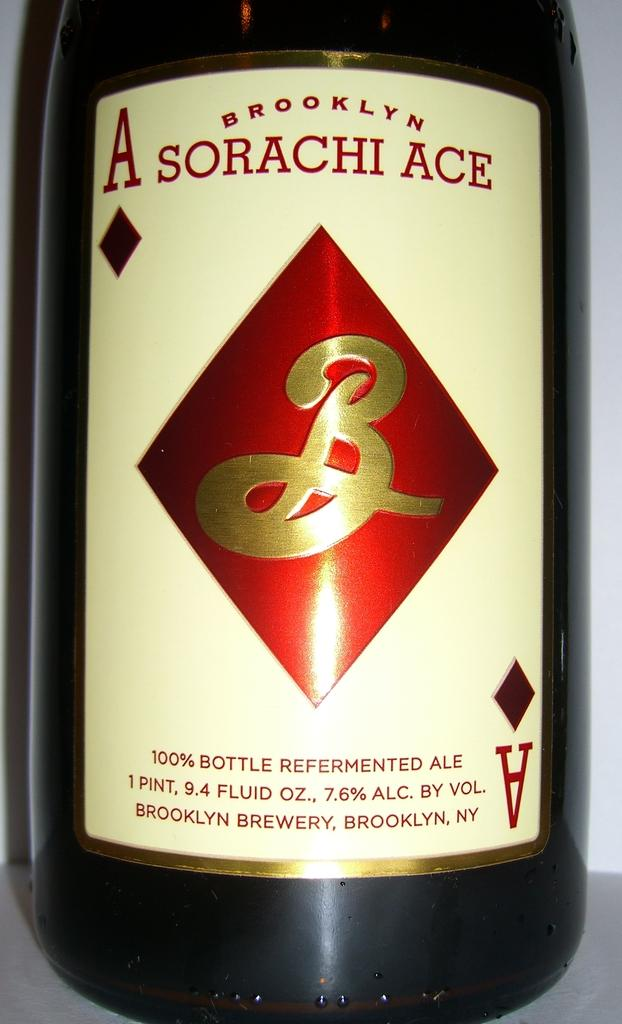<image>
Provide a brief description of the given image. A bottle of Sorachi Ace Beer from New Yor 